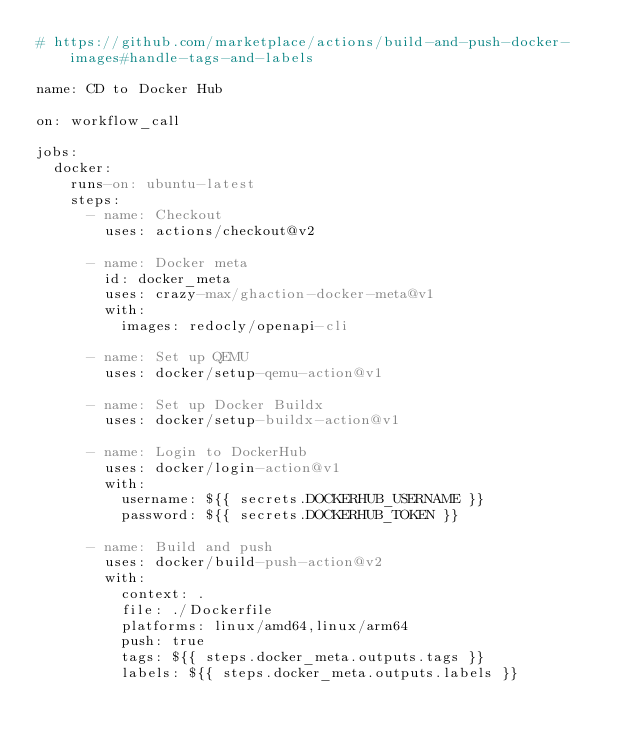Convert code to text. <code><loc_0><loc_0><loc_500><loc_500><_YAML_># https://github.com/marketplace/actions/build-and-push-docker-images#handle-tags-and-labels

name: CD to Docker Hub

on: workflow_call

jobs:
  docker:
    runs-on: ubuntu-latest
    steps:
      - name: Checkout
        uses: actions/checkout@v2

      - name: Docker meta
        id: docker_meta
        uses: crazy-max/ghaction-docker-meta@v1
        with:
          images: redocly/openapi-cli

      - name: Set up QEMU
        uses: docker/setup-qemu-action@v1

      - name: Set up Docker Buildx
        uses: docker/setup-buildx-action@v1

      - name: Login to DockerHub
        uses: docker/login-action@v1
        with:
          username: ${{ secrets.DOCKERHUB_USERNAME }}
          password: ${{ secrets.DOCKERHUB_TOKEN }}

      - name: Build and push
        uses: docker/build-push-action@v2
        with:
          context: .
          file: ./Dockerfile
          platforms: linux/amd64,linux/arm64
          push: true
          tags: ${{ steps.docker_meta.outputs.tags }}
          labels: ${{ steps.docker_meta.outputs.labels }}
</code> 